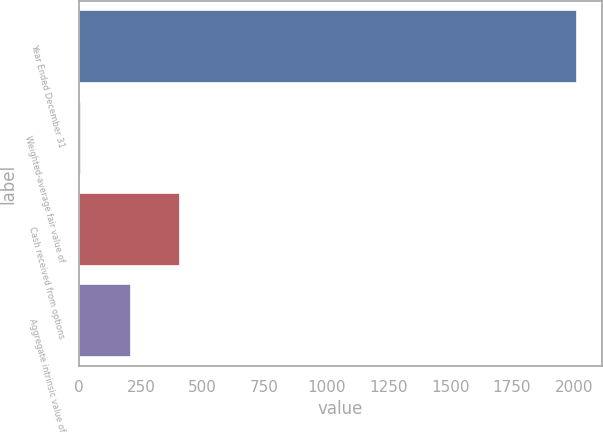Convert chart to OTSL. <chart><loc_0><loc_0><loc_500><loc_500><bar_chart><fcel>Year Ended December 31<fcel>Weighted-average fair value of<fcel>Cash received from options<fcel>Aggregate intrinsic value of<nl><fcel>2014<fcel>7.82<fcel>409.06<fcel>208.44<nl></chart> 